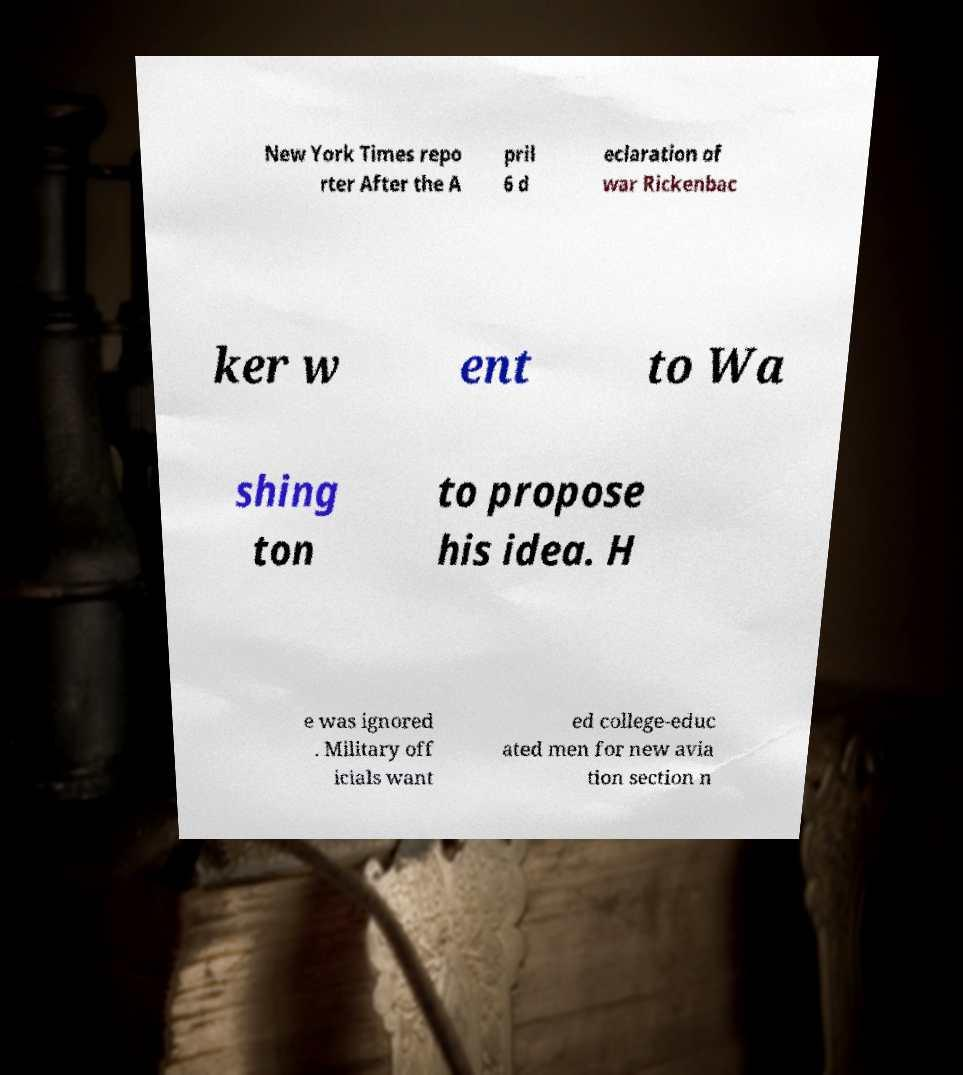What messages or text are displayed in this image? I need them in a readable, typed format. New York Times repo rter After the A pril 6 d eclaration of war Rickenbac ker w ent to Wa shing ton to propose his idea. H e was ignored . Military off icials want ed college-educ ated men for new avia tion section n 